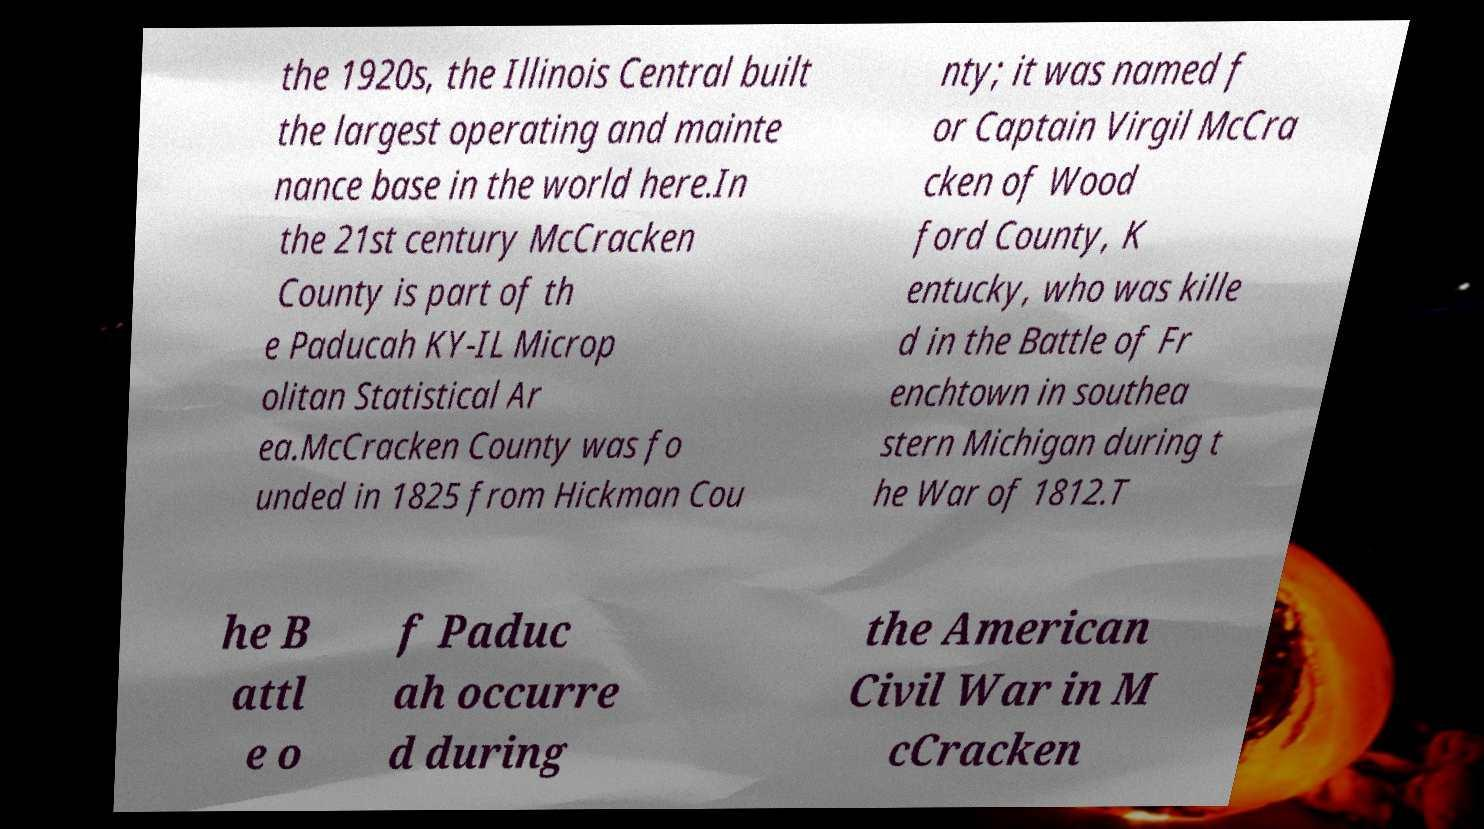I need the written content from this picture converted into text. Can you do that? the 1920s, the Illinois Central built the largest operating and mainte nance base in the world here.In the 21st century McCracken County is part of th e Paducah KY-IL Microp olitan Statistical Ar ea.McCracken County was fo unded in 1825 from Hickman Cou nty; it was named f or Captain Virgil McCra cken of Wood ford County, K entucky, who was kille d in the Battle of Fr enchtown in southea stern Michigan during t he War of 1812.T he B attl e o f Paduc ah occurre d during the American Civil War in M cCracken 